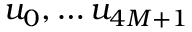<formula> <loc_0><loc_0><loc_500><loc_500>u _ { 0 } , \dots u _ { 4 M + 1 }</formula> 